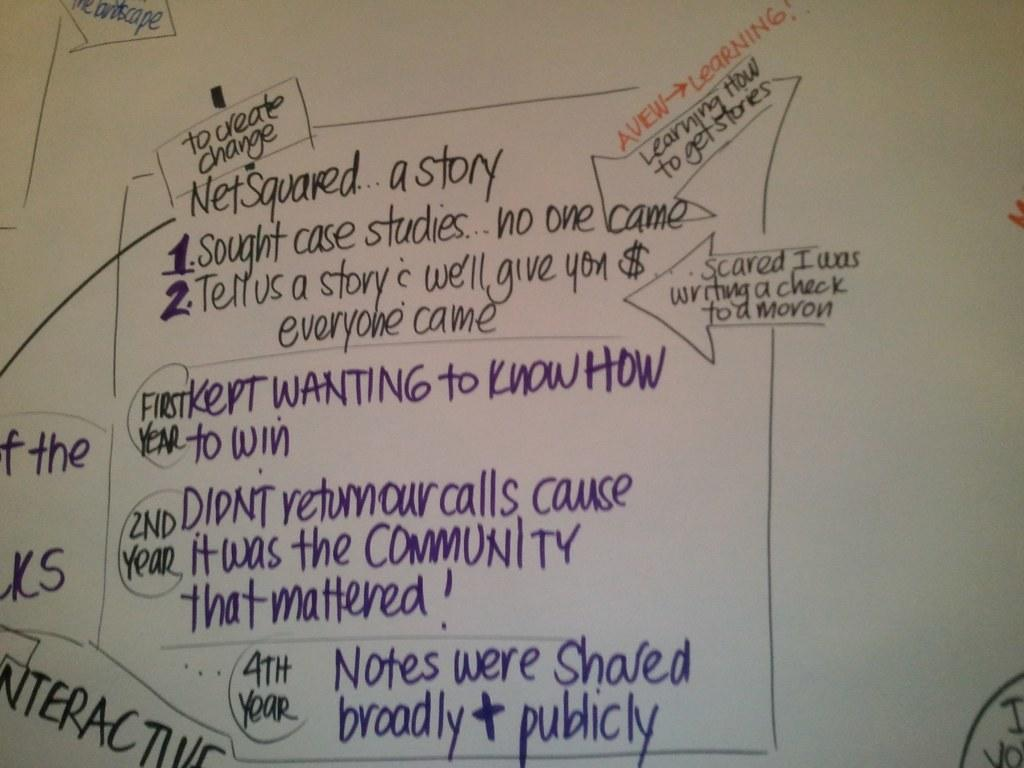Provide a one-sentence caption for the provided image. White board which says "Net Squared" on it. 